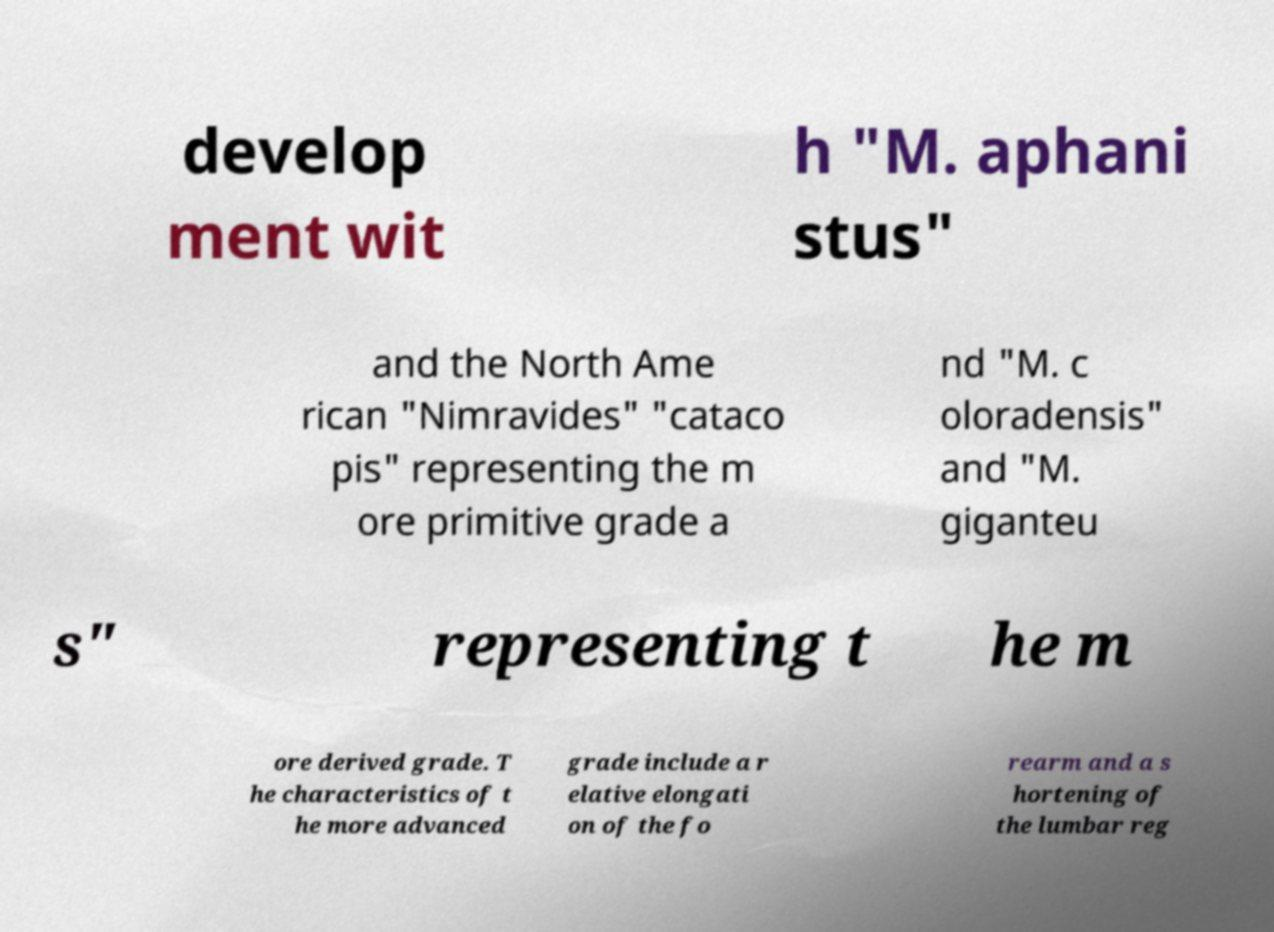Can you read and provide the text displayed in the image?This photo seems to have some interesting text. Can you extract and type it out for me? develop ment wit h "M. aphani stus" and the North Ame rican "Nimravides" "cataco pis" representing the m ore primitive grade a nd "M. c oloradensis" and "M. giganteu s" representing t he m ore derived grade. T he characteristics of t he more advanced grade include a r elative elongati on of the fo rearm and a s hortening of the lumbar reg 